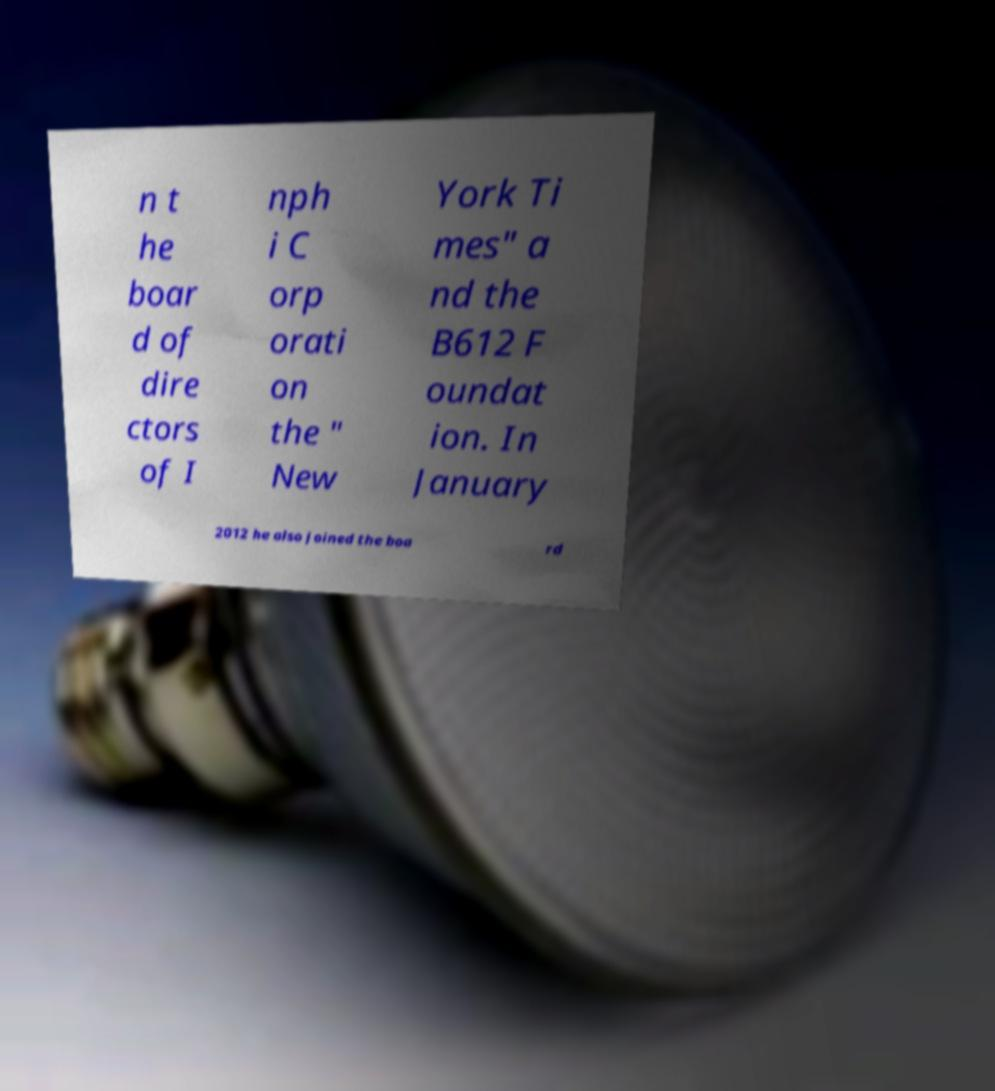There's text embedded in this image that I need extracted. Can you transcribe it verbatim? n t he boar d of dire ctors of I nph i C orp orati on the " New York Ti mes" a nd the B612 F oundat ion. In January 2012 he also joined the boa rd 